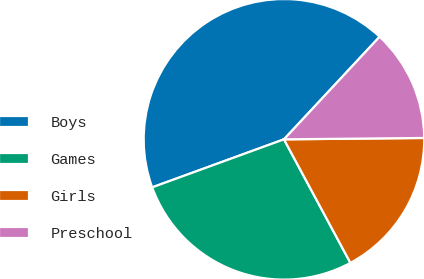<chart> <loc_0><loc_0><loc_500><loc_500><pie_chart><fcel>Boys<fcel>Games<fcel>Girls<fcel>Preschool<nl><fcel>42.5%<fcel>27.29%<fcel>17.3%<fcel>12.9%<nl></chart> 